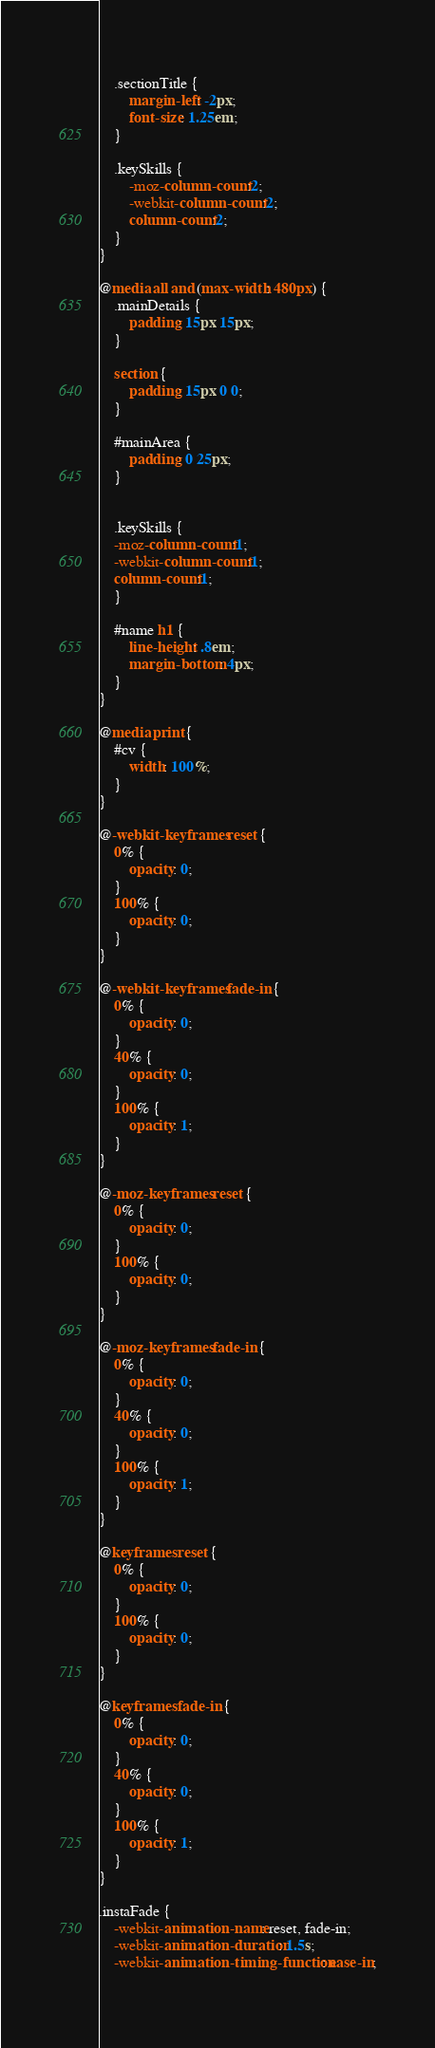Convert code to text. <code><loc_0><loc_0><loc_500><loc_500><_CSS_>	
	.sectionTitle {
		margin-left: -2px;
		font-size: 1.25em;
	}
	
	.keySkills {
		-moz-column-count:2;
		-webkit-column-count:2;
		column-count:2;
	}
}

@media all and (max-width: 480px) {
	.mainDetails {
		padding: 15px 15px;
	}
	
	section {
		padding: 15px 0 0;
	}
	
	#mainArea {
		padding: 0 25px;
	}

	
	.keySkills {
	-moz-column-count:1;
	-webkit-column-count:1;
	column-count:1;
	}
	
	#name h1 {
		line-height: .8em;
		margin-bottom: 4px;
	}
}

@media print {
    #cv {
        width: 100%;
    }
}

@-webkit-keyframes reset {
	0% {
		opacity: 0;
	}
	100% {
		opacity: 0;
	}
}

@-webkit-keyframes fade-in {
	0% {
		opacity: 0;
	}
	40% {
		opacity: 0;
	}
	100% {
		opacity: 1;
	}
}

@-moz-keyframes reset {
	0% {
		opacity: 0;
	}
	100% {
		opacity: 0;
	}
}

@-moz-keyframes fade-in {
	0% {
		opacity: 0;
	}
	40% {
		opacity: 0;
	}
	100% {
		opacity: 1;
	}
}

@keyframes reset {
	0% {
		opacity: 0;
	}
	100% {
		opacity: 0;
	}
}

@keyframes fade-in {
	0% {
		opacity: 0;
	}
	40% {
		opacity: 0;
	}
	100% {
		opacity: 1;
	}
}

.instaFade {
    -webkit-animation-name: reset, fade-in;
    -webkit-animation-duration: 1.5s;
    -webkit-animation-timing-function: ease-in;
	</code> 